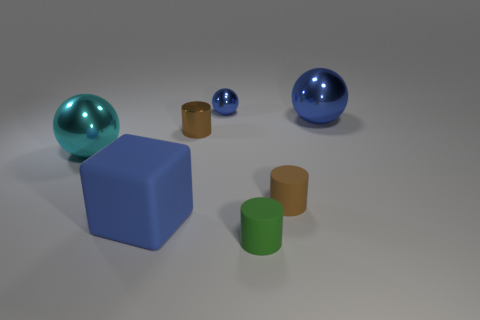Subtract all blocks. How many objects are left? 6 Add 4 big blue balls. How many big blue balls are left? 5 Add 1 large blue shiny balls. How many large blue shiny balls exist? 2 Subtract 0 yellow blocks. How many objects are left? 7 Subtract all small shiny objects. Subtract all large cyan shiny things. How many objects are left? 4 